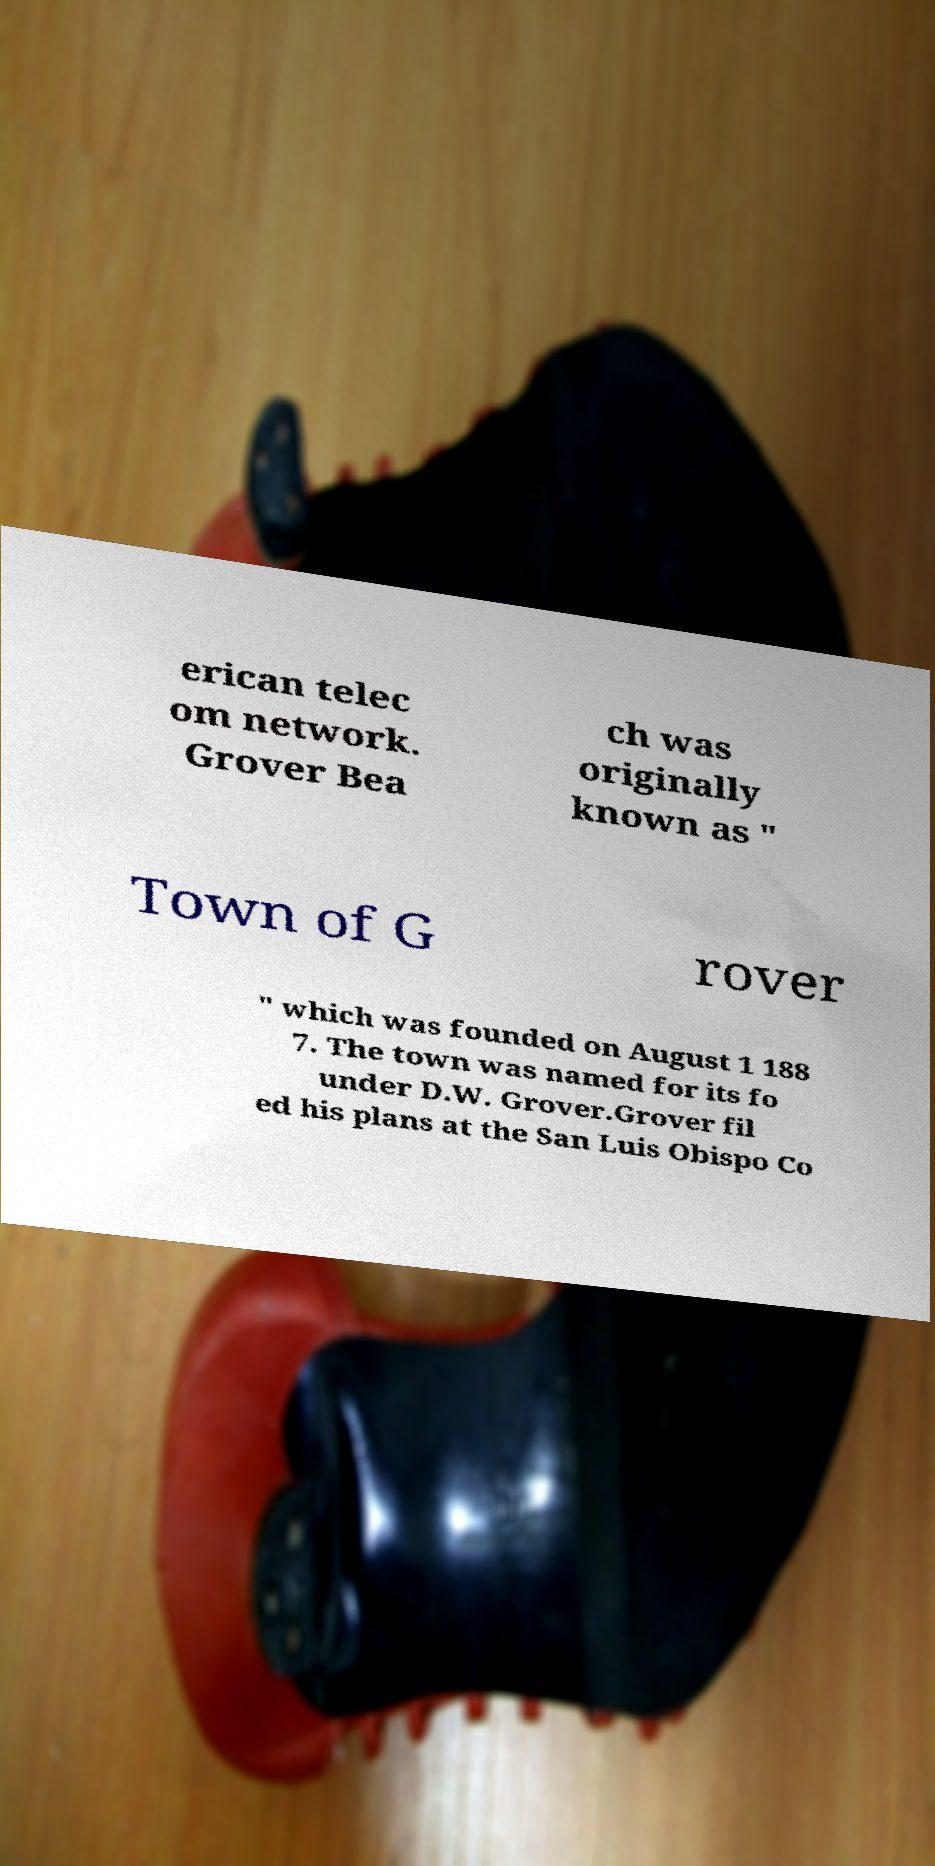I need the written content from this picture converted into text. Can you do that? erican telec om network. Grover Bea ch was originally known as " Town of G rover " which was founded on August 1 188 7. The town was named for its fo under D.W. Grover.Grover fil ed his plans at the San Luis Obispo Co 